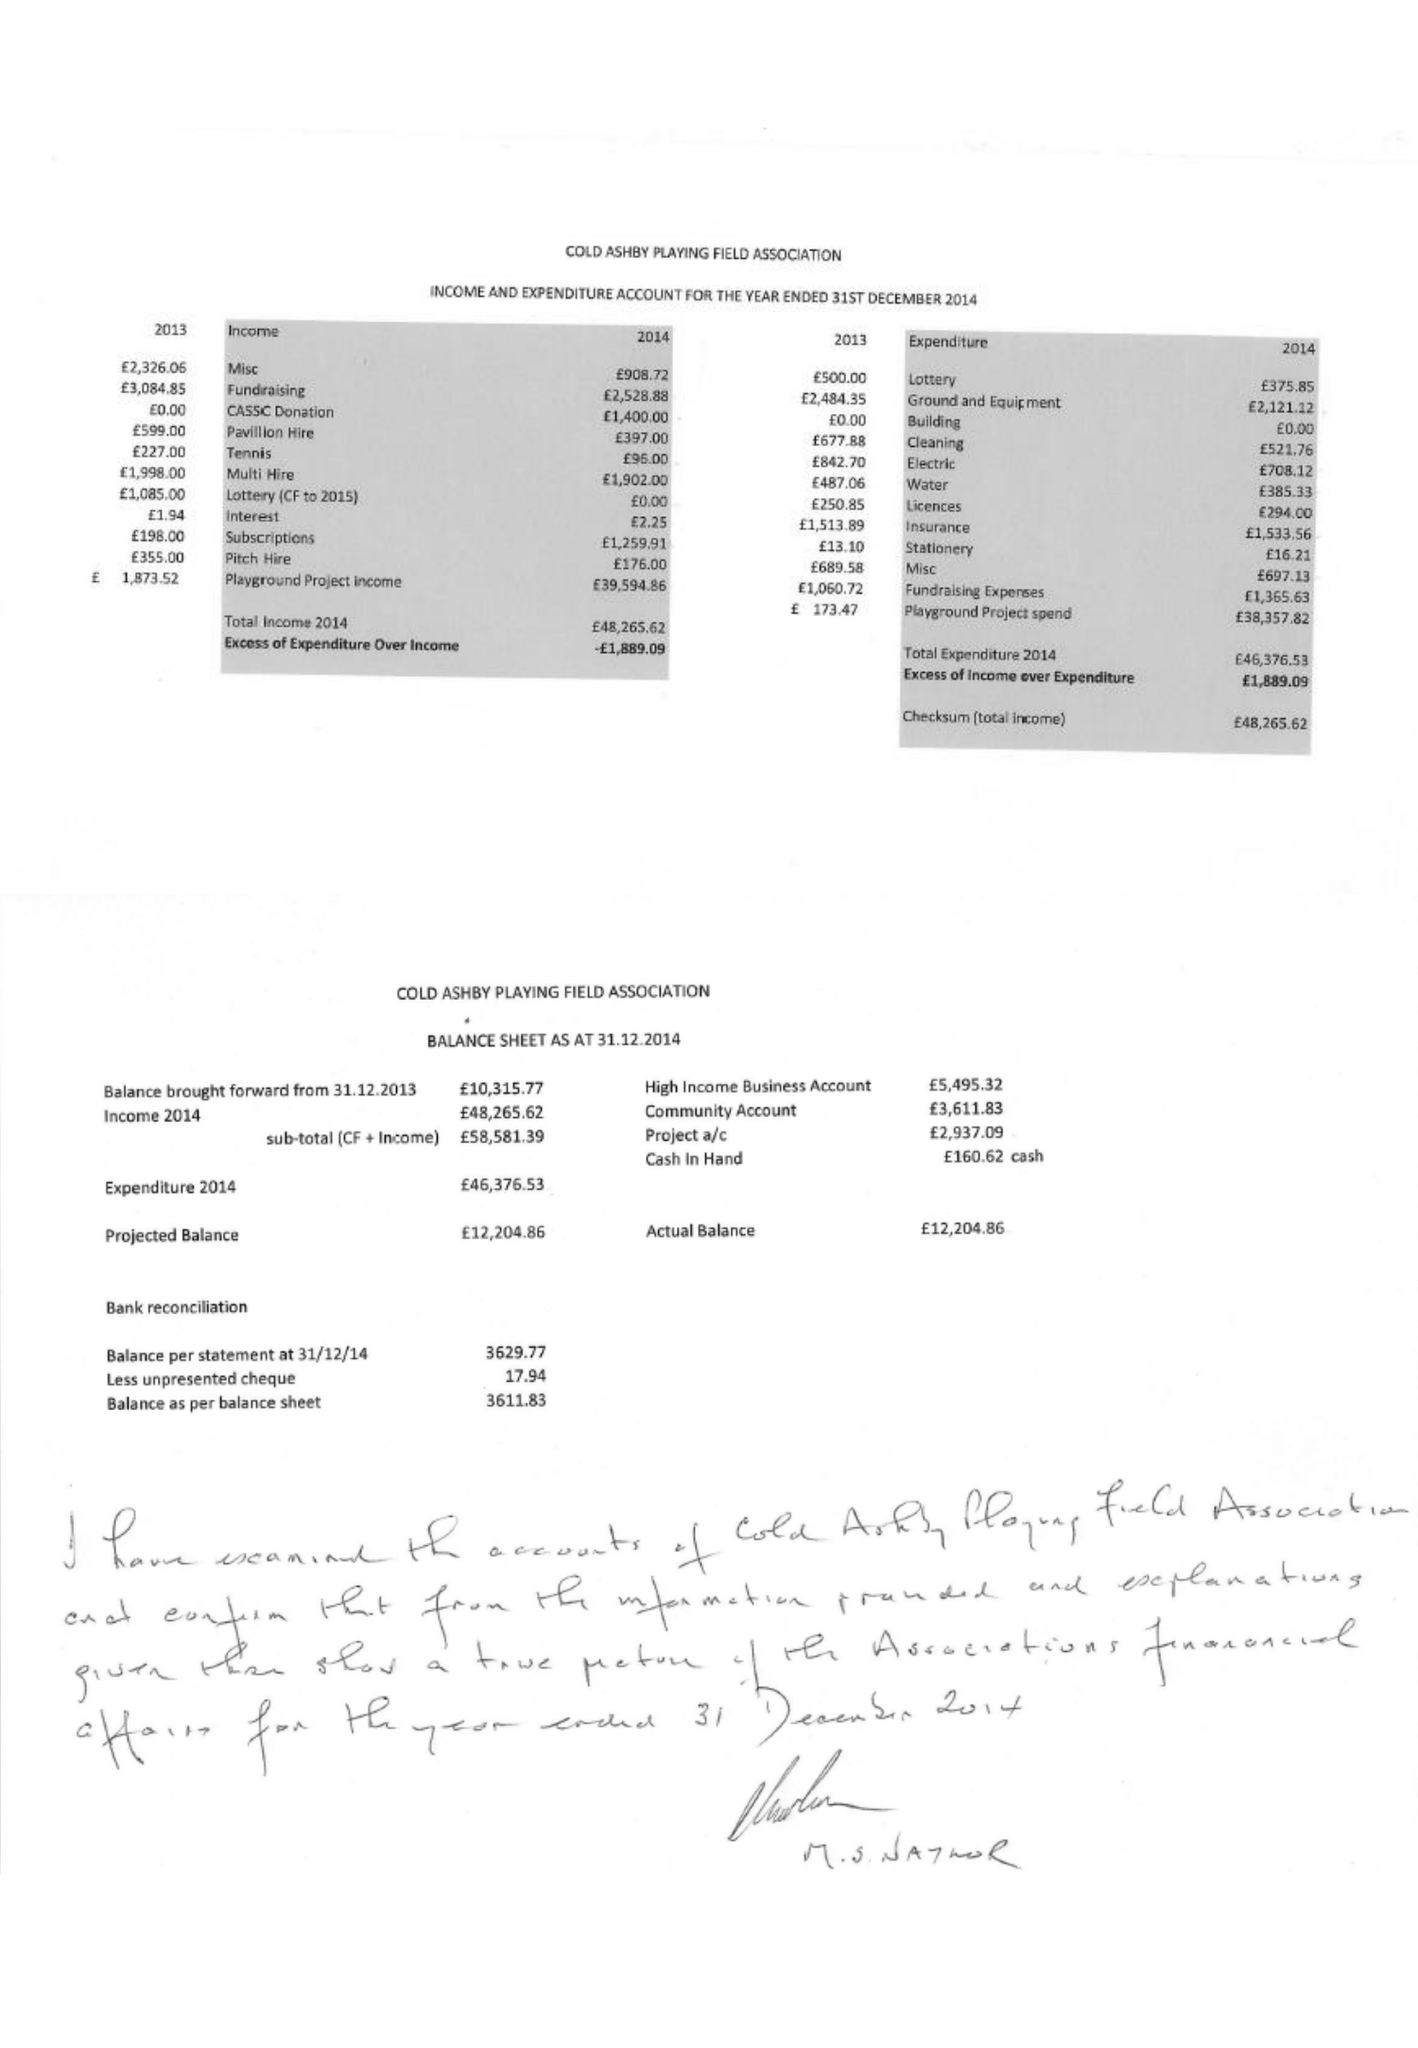What is the value for the charity_name?
Answer the question using a single word or phrase. Cold Ashby Playing Fields Association 